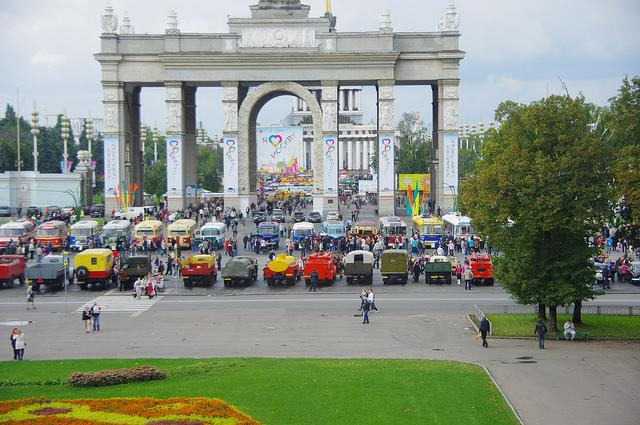The signs are expressing their love for which city?

Choices:
A) manchester
B) moscow
C) milan
D) manila moscow 